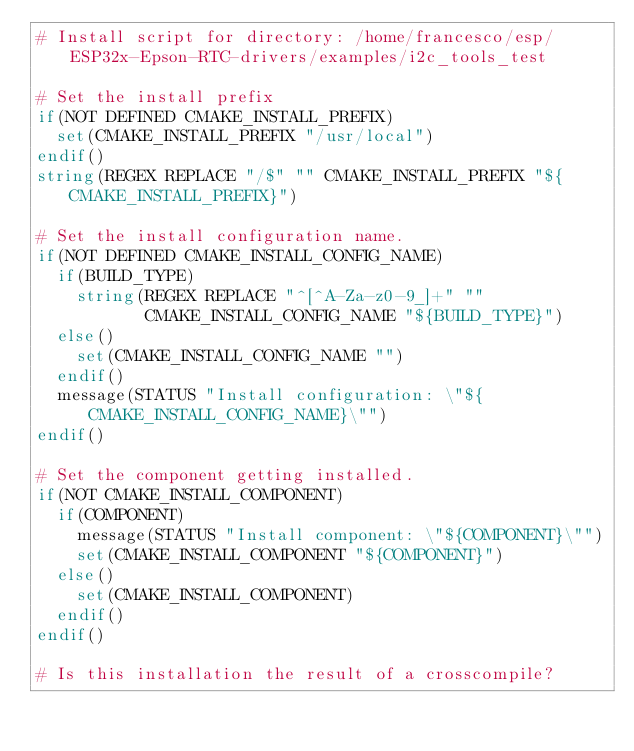Convert code to text. <code><loc_0><loc_0><loc_500><loc_500><_CMake_># Install script for directory: /home/francesco/esp/ESP32x-Epson-RTC-drivers/examples/i2c_tools_test

# Set the install prefix
if(NOT DEFINED CMAKE_INSTALL_PREFIX)
  set(CMAKE_INSTALL_PREFIX "/usr/local")
endif()
string(REGEX REPLACE "/$" "" CMAKE_INSTALL_PREFIX "${CMAKE_INSTALL_PREFIX}")

# Set the install configuration name.
if(NOT DEFINED CMAKE_INSTALL_CONFIG_NAME)
  if(BUILD_TYPE)
    string(REGEX REPLACE "^[^A-Za-z0-9_]+" ""
           CMAKE_INSTALL_CONFIG_NAME "${BUILD_TYPE}")
  else()
    set(CMAKE_INSTALL_CONFIG_NAME "")
  endif()
  message(STATUS "Install configuration: \"${CMAKE_INSTALL_CONFIG_NAME}\"")
endif()

# Set the component getting installed.
if(NOT CMAKE_INSTALL_COMPONENT)
  if(COMPONENT)
    message(STATUS "Install component: \"${COMPONENT}\"")
    set(CMAKE_INSTALL_COMPONENT "${COMPONENT}")
  else()
    set(CMAKE_INSTALL_COMPONENT)
  endif()
endif()

# Is this installation the result of a crosscompile?</code> 